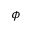<formula> <loc_0><loc_0><loc_500><loc_500>\phi</formula> 